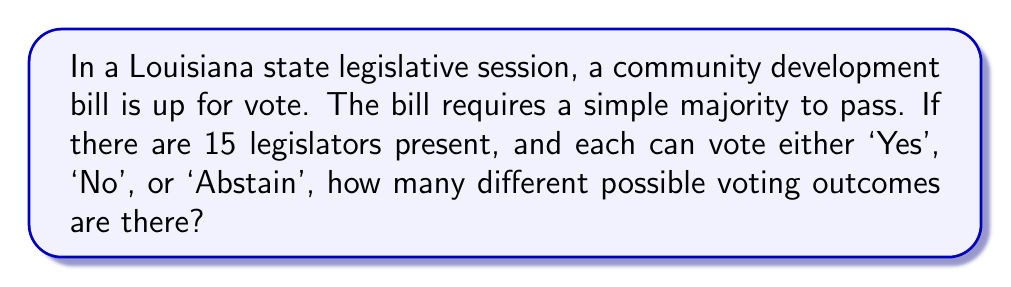Provide a solution to this math problem. Let's approach this step-by-step:

1) Each legislator has 3 choices: 'Yes', 'No', or 'Abstain'.

2) There are 15 legislators voting.

3) This scenario can be modeled as a combination with repetition problem, where we have 3 choices that can be repeated 15 times (once for each legislator).

4) The formula for combinations with repetition is:

   $$ n^r $$

   Where $n$ is the number of choices and $r$ is the number of times the choice is made.

5) In this case, $n = 3$ (Yes, No, Abstain) and $r = 15$ (15 legislators).

6) Therefore, the number of possible voting outcomes is:

   $$ 3^{15} $$

7) Calculating this:

   $$ 3^{15} = 14,348,907 $$

This large number reflects all possible combinations of votes, including outcomes where the bill passes, fails, or results in a tie.
Answer: $3^{15} = 14,348,907$ 